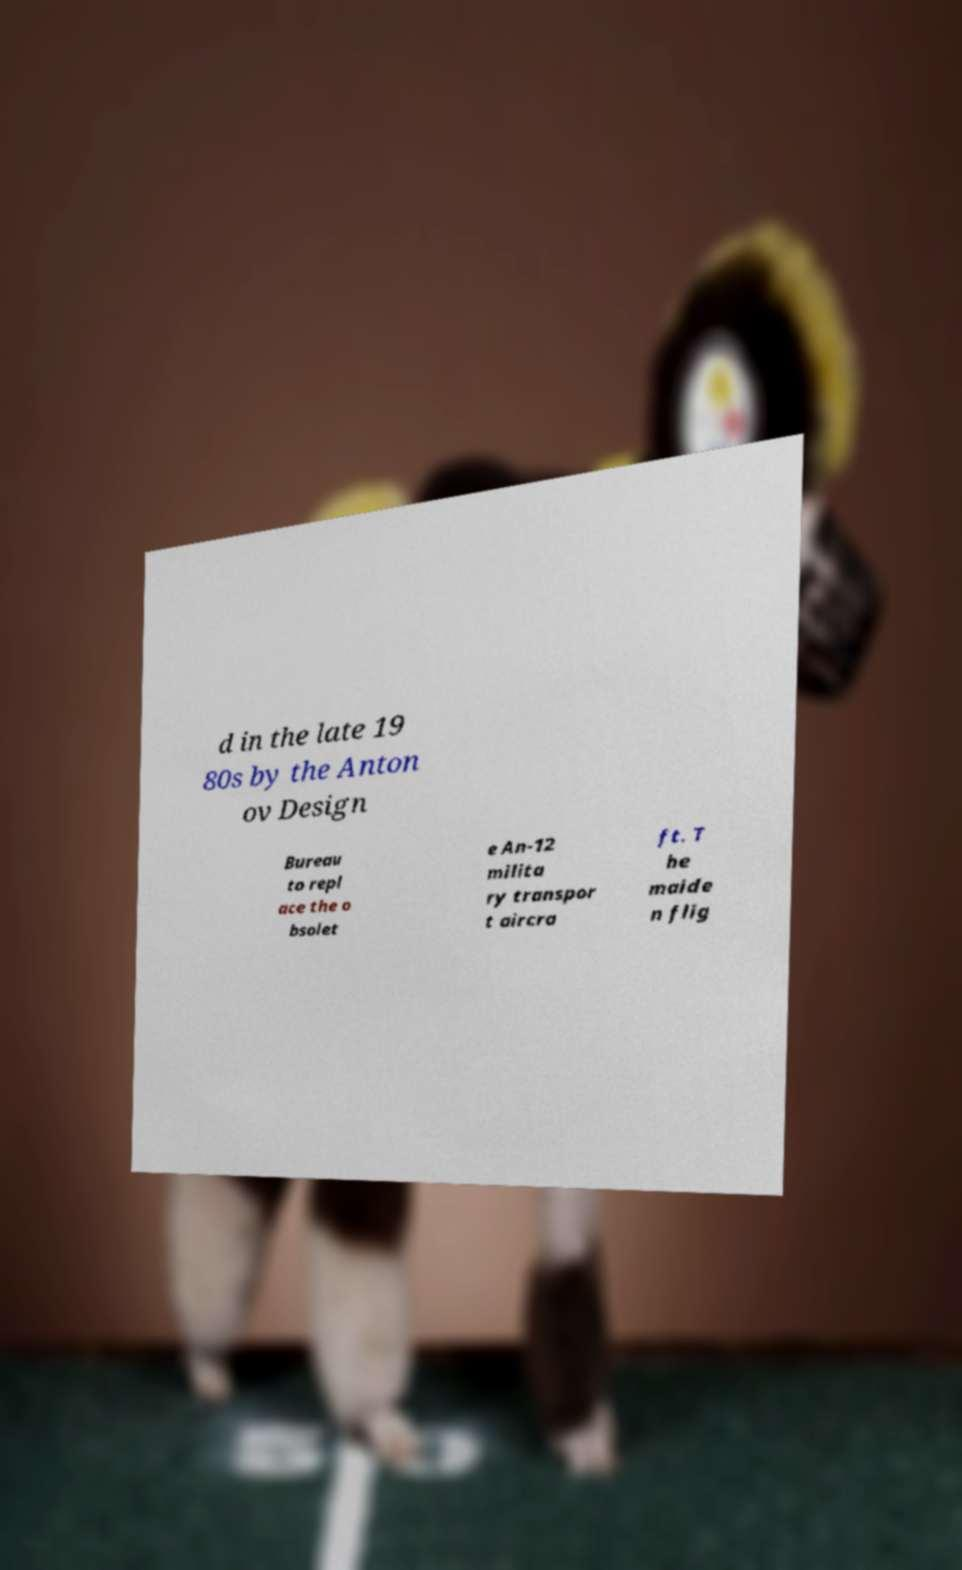For documentation purposes, I need the text within this image transcribed. Could you provide that? d in the late 19 80s by the Anton ov Design Bureau to repl ace the o bsolet e An-12 milita ry transpor t aircra ft. T he maide n flig 